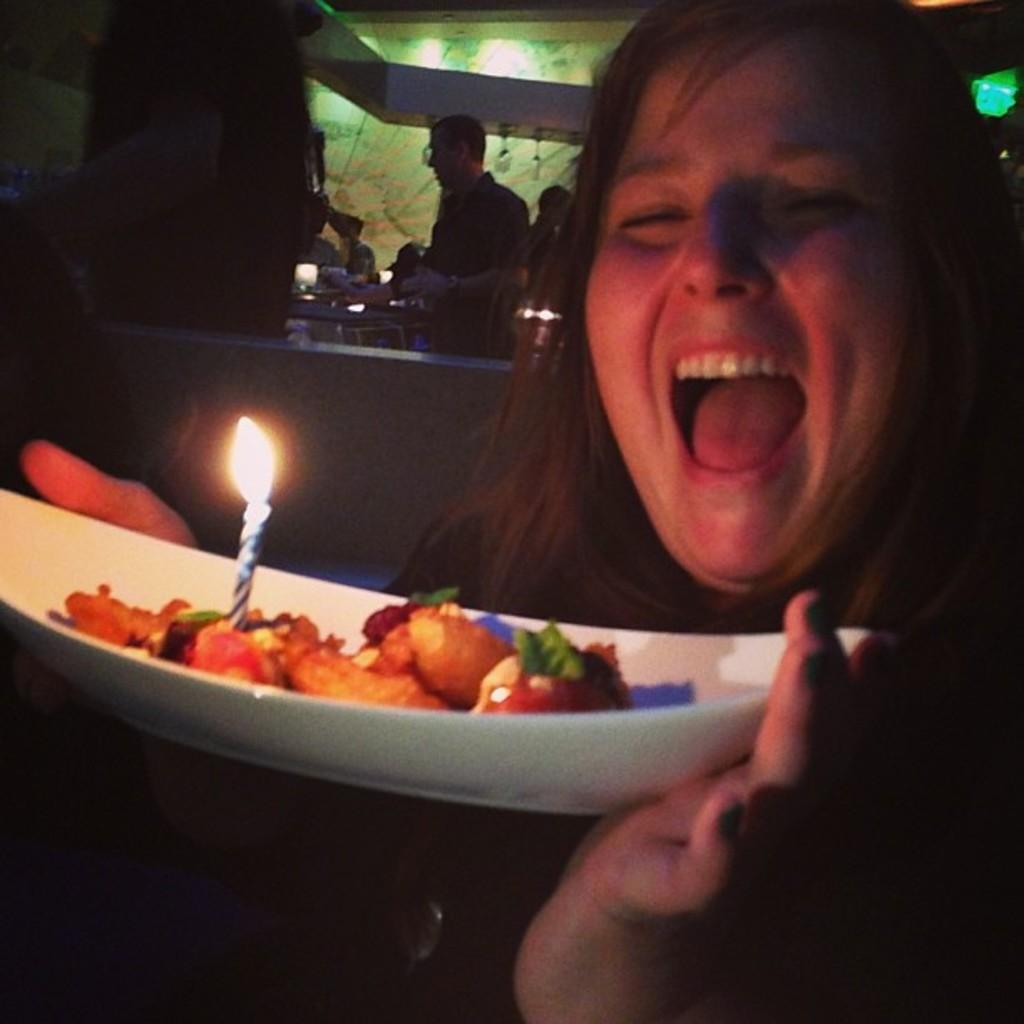Who is present in the image? There is a woman in the image. What is the woman holding? The woman is holding a bowl. What is inside the bowl? The bowl contains a candle and wood. What can be seen in the background of the image? There are persons and a wall in the background of the image. What type of part is being used to cover the light in the image? There is no part or light present in the image; it features a woman holding a bowl with a candle and wood. 